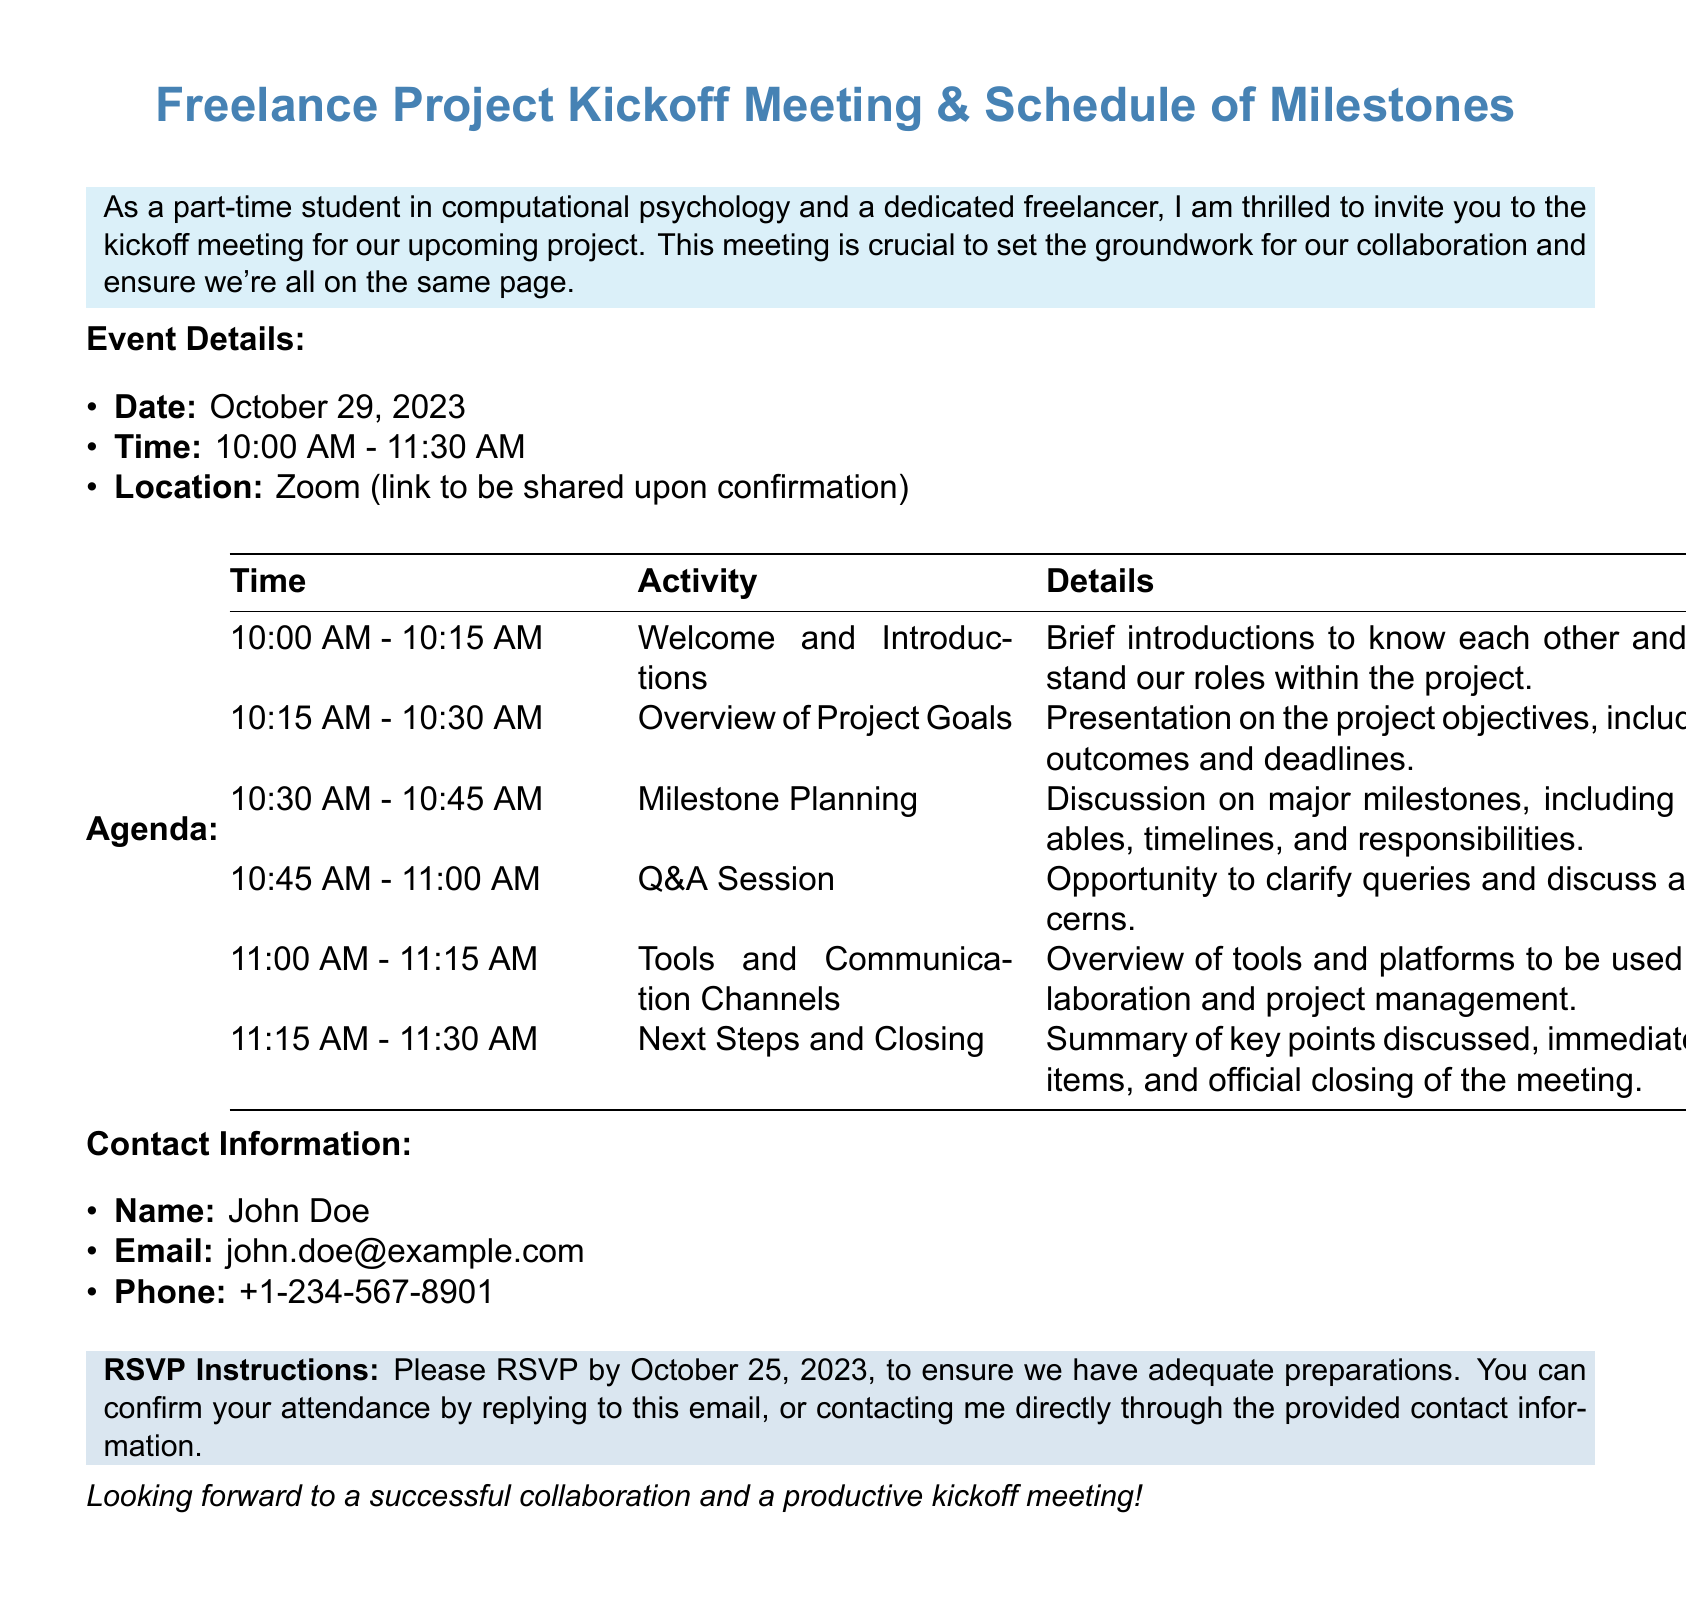What is the date of the kickoff meeting? The date for the kickoff meeting is explicitly mentioned in the document.
Answer: October 29, 2023 What time does the meeting start? The start time for the meeting is listed under the event details.
Answer: 10:00 AM Who is the contact person for the event? The document specifies the name of the contact person for the event.
Answer: John Doe What is the duration of the meeting? The meeting time is given in the event details, allowing for calculation of duration.
Answer: 1 hour and 30 minutes What should attendees do by October 25, 2023? This date is provided in the RSVP instructions, indicating an required action from attendees.
Answer: RSVP What platform will the meeting be held on? The details of the meeting location specify the platform to be used.
Answer: Zoom What is the first activity listed in the agenda? The agenda outlines various activities in sequence, starting with the first one.
Answer: Welcome and Introductions How many milestones will be discussed in the meeting? The milestone discussion is mentioned as a segment of the agenda, implying there are multiple.
Answer: Major milestones (exact number not specified) What is the purpose of the Q&A session? The document states that this session is an opportunity for attendees to clarify queries.
Answer: To clarify queries 